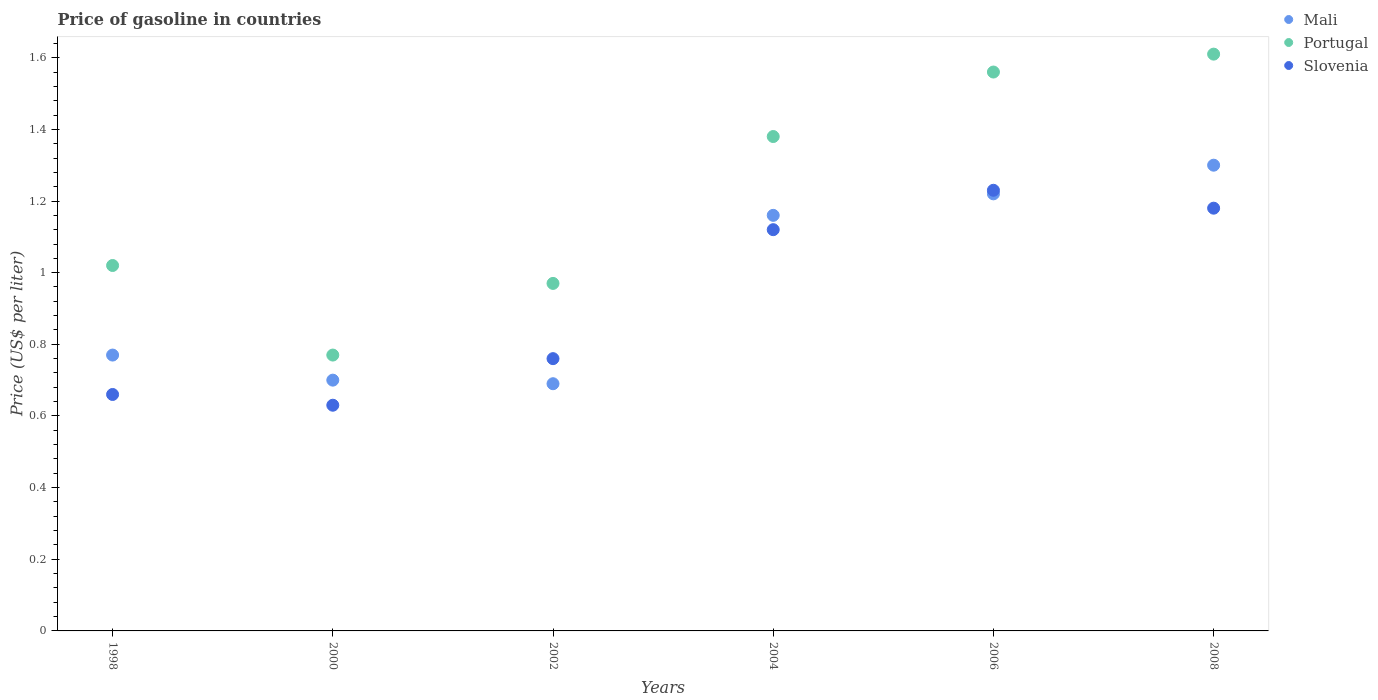How many different coloured dotlines are there?
Give a very brief answer. 3. What is the price of gasoline in Slovenia in 2004?
Keep it short and to the point. 1.12. Across all years, what is the minimum price of gasoline in Slovenia?
Keep it short and to the point. 0.63. In which year was the price of gasoline in Slovenia maximum?
Provide a short and direct response. 2006. In which year was the price of gasoline in Portugal minimum?
Provide a succinct answer. 2000. What is the total price of gasoline in Mali in the graph?
Your response must be concise. 5.84. What is the difference between the price of gasoline in Mali in 1998 and that in 2002?
Your answer should be compact. 0.08. What is the difference between the price of gasoline in Portugal in 2000 and the price of gasoline in Slovenia in 2008?
Offer a very short reply. -0.41. What is the average price of gasoline in Portugal per year?
Offer a very short reply. 1.22. In the year 2006, what is the difference between the price of gasoline in Slovenia and price of gasoline in Portugal?
Make the answer very short. -0.33. What is the ratio of the price of gasoline in Slovenia in 2000 to that in 2004?
Your response must be concise. 0.56. Is the difference between the price of gasoline in Slovenia in 1998 and 2008 greater than the difference between the price of gasoline in Portugal in 1998 and 2008?
Ensure brevity in your answer.  Yes. What is the difference between the highest and the second highest price of gasoline in Slovenia?
Your response must be concise. 0.05. What is the difference between the highest and the lowest price of gasoline in Mali?
Make the answer very short. 0.61. Is the sum of the price of gasoline in Portugal in 2006 and 2008 greater than the maximum price of gasoline in Slovenia across all years?
Make the answer very short. Yes. Is it the case that in every year, the sum of the price of gasoline in Mali and price of gasoline in Portugal  is greater than the price of gasoline in Slovenia?
Provide a succinct answer. Yes. How many years are there in the graph?
Offer a very short reply. 6. Does the graph contain any zero values?
Your response must be concise. No. Where does the legend appear in the graph?
Give a very brief answer. Top right. How many legend labels are there?
Your answer should be compact. 3. What is the title of the graph?
Keep it short and to the point. Price of gasoline in countries. What is the label or title of the Y-axis?
Make the answer very short. Price (US$ per liter). What is the Price (US$ per liter) in Mali in 1998?
Your answer should be compact. 0.77. What is the Price (US$ per liter) of Portugal in 1998?
Your answer should be compact. 1.02. What is the Price (US$ per liter) of Slovenia in 1998?
Make the answer very short. 0.66. What is the Price (US$ per liter) in Mali in 2000?
Make the answer very short. 0.7. What is the Price (US$ per liter) of Portugal in 2000?
Your answer should be compact. 0.77. What is the Price (US$ per liter) of Slovenia in 2000?
Provide a succinct answer. 0.63. What is the Price (US$ per liter) in Mali in 2002?
Your response must be concise. 0.69. What is the Price (US$ per liter) in Slovenia in 2002?
Your answer should be compact. 0.76. What is the Price (US$ per liter) in Mali in 2004?
Provide a short and direct response. 1.16. What is the Price (US$ per liter) in Portugal in 2004?
Give a very brief answer. 1.38. What is the Price (US$ per liter) in Slovenia in 2004?
Provide a short and direct response. 1.12. What is the Price (US$ per liter) in Mali in 2006?
Give a very brief answer. 1.22. What is the Price (US$ per liter) of Portugal in 2006?
Your answer should be very brief. 1.56. What is the Price (US$ per liter) in Slovenia in 2006?
Make the answer very short. 1.23. What is the Price (US$ per liter) of Portugal in 2008?
Your response must be concise. 1.61. What is the Price (US$ per liter) of Slovenia in 2008?
Offer a very short reply. 1.18. Across all years, what is the maximum Price (US$ per liter) of Mali?
Provide a succinct answer. 1.3. Across all years, what is the maximum Price (US$ per liter) in Portugal?
Offer a terse response. 1.61. Across all years, what is the maximum Price (US$ per liter) of Slovenia?
Your answer should be compact. 1.23. Across all years, what is the minimum Price (US$ per liter) of Mali?
Provide a succinct answer. 0.69. Across all years, what is the minimum Price (US$ per liter) of Portugal?
Keep it short and to the point. 0.77. Across all years, what is the minimum Price (US$ per liter) of Slovenia?
Keep it short and to the point. 0.63. What is the total Price (US$ per liter) in Mali in the graph?
Offer a very short reply. 5.84. What is the total Price (US$ per liter) in Portugal in the graph?
Keep it short and to the point. 7.31. What is the total Price (US$ per liter) of Slovenia in the graph?
Make the answer very short. 5.58. What is the difference between the Price (US$ per liter) of Mali in 1998 and that in 2000?
Offer a very short reply. 0.07. What is the difference between the Price (US$ per liter) in Portugal in 1998 and that in 2000?
Keep it short and to the point. 0.25. What is the difference between the Price (US$ per liter) in Mali in 1998 and that in 2002?
Keep it short and to the point. 0.08. What is the difference between the Price (US$ per liter) of Portugal in 1998 and that in 2002?
Offer a very short reply. 0.05. What is the difference between the Price (US$ per liter) in Slovenia in 1998 and that in 2002?
Provide a succinct answer. -0.1. What is the difference between the Price (US$ per liter) in Mali in 1998 and that in 2004?
Make the answer very short. -0.39. What is the difference between the Price (US$ per liter) in Portugal in 1998 and that in 2004?
Give a very brief answer. -0.36. What is the difference between the Price (US$ per liter) in Slovenia in 1998 and that in 2004?
Offer a very short reply. -0.46. What is the difference between the Price (US$ per liter) of Mali in 1998 and that in 2006?
Provide a succinct answer. -0.45. What is the difference between the Price (US$ per liter) of Portugal in 1998 and that in 2006?
Your answer should be very brief. -0.54. What is the difference between the Price (US$ per liter) of Slovenia in 1998 and that in 2006?
Ensure brevity in your answer.  -0.57. What is the difference between the Price (US$ per liter) of Mali in 1998 and that in 2008?
Your answer should be very brief. -0.53. What is the difference between the Price (US$ per liter) of Portugal in 1998 and that in 2008?
Ensure brevity in your answer.  -0.59. What is the difference between the Price (US$ per liter) in Slovenia in 1998 and that in 2008?
Give a very brief answer. -0.52. What is the difference between the Price (US$ per liter) of Slovenia in 2000 and that in 2002?
Make the answer very short. -0.13. What is the difference between the Price (US$ per liter) of Mali in 2000 and that in 2004?
Your response must be concise. -0.46. What is the difference between the Price (US$ per liter) in Portugal in 2000 and that in 2004?
Keep it short and to the point. -0.61. What is the difference between the Price (US$ per liter) of Slovenia in 2000 and that in 2004?
Offer a terse response. -0.49. What is the difference between the Price (US$ per liter) of Mali in 2000 and that in 2006?
Provide a short and direct response. -0.52. What is the difference between the Price (US$ per liter) in Portugal in 2000 and that in 2006?
Provide a succinct answer. -0.79. What is the difference between the Price (US$ per liter) of Mali in 2000 and that in 2008?
Provide a succinct answer. -0.6. What is the difference between the Price (US$ per liter) of Portugal in 2000 and that in 2008?
Make the answer very short. -0.84. What is the difference between the Price (US$ per liter) in Slovenia in 2000 and that in 2008?
Your answer should be very brief. -0.55. What is the difference between the Price (US$ per liter) in Mali in 2002 and that in 2004?
Offer a terse response. -0.47. What is the difference between the Price (US$ per liter) in Portugal in 2002 and that in 2004?
Keep it short and to the point. -0.41. What is the difference between the Price (US$ per liter) in Slovenia in 2002 and that in 2004?
Offer a terse response. -0.36. What is the difference between the Price (US$ per liter) of Mali in 2002 and that in 2006?
Give a very brief answer. -0.53. What is the difference between the Price (US$ per liter) in Portugal in 2002 and that in 2006?
Your answer should be compact. -0.59. What is the difference between the Price (US$ per liter) in Slovenia in 2002 and that in 2006?
Keep it short and to the point. -0.47. What is the difference between the Price (US$ per liter) in Mali in 2002 and that in 2008?
Your response must be concise. -0.61. What is the difference between the Price (US$ per liter) in Portugal in 2002 and that in 2008?
Provide a short and direct response. -0.64. What is the difference between the Price (US$ per liter) in Slovenia in 2002 and that in 2008?
Make the answer very short. -0.42. What is the difference between the Price (US$ per liter) of Mali in 2004 and that in 2006?
Your answer should be very brief. -0.06. What is the difference between the Price (US$ per liter) of Portugal in 2004 and that in 2006?
Your response must be concise. -0.18. What is the difference between the Price (US$ per liter) in Slovenia in 2004 and that in 2006?
Provide a short and direct response. -0.11. What is the difference between the Price (US$ per liter) in Mali in 2004 and that in 2008?
Make the answer very short. -0.14. What is the difference between the Price (US$ per liter) in Portugal in 2004 and that in 2008?
Give a very brief answer. -0.23. What is the difference between the Price (US$ per liter) of Slovenia in 2004 and that in 2008?
Offer a terse response. -0.06. What is the difference between the Price (US$ per liter) of Mali in 2006 and that in 2008?
Keep it short and to the point. -0.08. What is the difference between the Price (US$ per liter) of Portugal in 2006 and that in 2008?
Your answer should be very brief. -0.05. What is the difference between the Price (US$ per liter) in Slovenia in 2006 and that in 2008?
Your answer should be very brief. 0.05. What is the difference between the Price (US$ per liter) of Mali in 1998 and the Price (US$ per liter) of Portugal in 2000?
Give a very brief answer. 0. What is the difference between the Price (US$ per liter) in Mali in 1998 and the Price (US$ per liter) in Slovenia in 2000?
Your response must be concise. 0.14. What is the difference between the Price (US$ per liter) of Portugal in 1998 and the Price (US$ per liter) of Slovenia in 2000?
Keep it short and to the point. 0.39. What is the difference between the Price (US$ per liter) in Mali in 1998 and the Price (US$ per liter) in Portugal in 2002?
Your response must be concise. -0.2. What is the difference between the Price (US$ per liter) of Mali in 1998 and the Price (US$ per liter) of Slovenia in 2002?
Provide a succinct answer. 0.01. What is the difference between the Price (US$ per liter) of Portugal in 1998 and the Price (US$ per liter) of Slovenia in 2002?
Keep it short and to the point. 0.26. What is the difference between the Price (US$ per liter) in Mali in 1998 and the Price (US$ per liter) in Portugal in 2004?
Provide a succinct answer. -0.61. What is the difference between the Price (US$ per liter) in Mali in 1998 and the Price (US$ per liter) in Slovenia in 2004?
Make the answer very short. -0.35. What is the difference between the Price (US$ per liter) in Portugal in 1998 and the Price (US$ per liter) in Slovenia in 2004?
Keep it short and to the point. -0.1. What is the difference between the Price (US$ per liter) of Mali in 1998 and the Price (US$ per liter) of Portugal in 2006?
Keep it short and to the point. -0.79. What is the difference between the Price (US$ per liter) in Mali in 1998 and the Price (US$ per liter) in Slovenia in 2006?
Keep it short and to the point. -0.46. What is the difference between the Price (US$ per liter) in Portugal in 1998 and the Price (US$ per liter) in Slovenia in 2006?
Your answer should be compact. -0.21. What is the difference between the Price (US$ per liter) of Mali in 1998 and the Price (US$ per liter) of Portugal in 2008?
Offer a very short reply. -0.84. What is the difference between the Price (US$ per liter) in Mali in 1998 and the Price (US$ per liter) in Slovenia in 2008?
Offer a very short reply. -0.41. What is the difference between the Price (US$ per liter) of Portugal in 1998 and the Price (US$ per liter) of Slovenia in 2008?
Offer a very short reply. -0.16. What is the difference between the Price (US$ per liter) in Mali in 2000 and the Price (US$ per liter) in Portugal in 2002?
Provide a short and direct response. -0.27. What is the difference between the Price (US$ per liter) of Mali in 2000 and the Price (US$ per liter) of Slovenia in 2002?
Offer a very short reply. -0.06. What is the difference between the Price (US$ per liter) in Mali in 2000 and the Price (US$ per liter) in Portugal in 2004?
Your response must be concise. -0.68. What is the difference between the Price (US$ per liter) in Mali in 2000 and the Price (US$ per liter) in Slovenia in 2004?
Ensure brevity in your answer.  -0.42. What is the difference between the Price (US$ per liter) of Portugal in 2000 and the Price (US$ per liter) of Slovenia in 2004?
Provide a succinct answer. -0.35. What is the difference between the Price (US$ per liter) in Mali in 2000 and the Price (US$ per liter) in Portugal in 2006?
Give a very brief answer. -0.86. What is the difference between the Price (US$ per liter) of Mali in 2000 and the Price (US$ per liter) of Slovenia in 2006?
Offer a very short reply. -0.53. What is the difference between the Price (US$ per liter) of Portugal in 2000 and the Price (US$ per liter) of Slovenia in 2006?
Your answer should be compact. -0.46. What is the difference between the Price (US$ per liter) in Mali in 2000 and the Price (US$ per liter) in Portugal in 2008?
Ensure brevity in your answer.  -0.91. What is the difference between the Price (US$ per liter) of Mali in 2000 and the Price (US$ per liter) of Slovenia in 2008?
Offer a very short reply. -0.48. What is the difference between the Price (US$ per liter) of Portugal in 2000 and the Price (US$ per liter) of Slovenia in 2008?
Provide a succinct answer. -0.41. What is the difference between the Price (US$ per liter) in Mali in 2002 and the Price (US$ per liter) in Portugal in 2004?
Your answer should be very brief. -0.69. What is the difference between the Price (US$ per liter) in Mali in 2002 and the Price (US$ per liter) in Slovenia in 2004?
Your answer should be compact. -0.43. What is the difference between the Price (US$ per liter) in Portugal in 2002 and the Price (US$ per liter) in Slovenia in 2004?
Ensure brevity in your answer.  -0.15. What is the difference between the Price (US$ per liter) of Mali in 2002 and the Price (US$ per liter) of Portugal in 2006?
Offer a very short reply. -0.87. What is the difference between the Price (US$ per liter) in Mali in 2002 and the Price (US$ per liter) in Slovenia in 2006?
Offer a very short reply. -0.54. What is the difference between the Price (US$ per liter) in Portugal in 2002 and the Price (US$ per liter) in Slovenia in 2006?
Keep it short and to the point. -0.26. What is the difference between the Price (US$ per liter) of Mali in 2002 and the Price (US$ per liter) of Portugal in 2008?
Ensure brevity in your answer.  -0.92. What is the difference between the Price (US$ per liter) in Mali in 2002 and the Price (US$ per liter) in Slovenia in 2008?
Provide a short and direct response. -0.49. What is the difference between the Price (US$ per liter) of Portugal in 2002 and the Price (US$ per liter) of Slovenia in 2008?
Make the answer very short. -0.21. What is the difference between the Price (US$ per liter) of Mali in 2004 and the Price (US$ per liter) of Portugal in 2006?
Keep it short and to the point. -0.4. What is the difference between the Price (US$ per liter) of Mali in 2004 and the Price (US$ per liter) of Slovenia in 2006?
Your answer should be compact. -0.07. What is the difference between the Price (US$ per liter) in Portugal in 2004 and the Price (US$ per liter) in Slovenia in 2006?
Your response must be concise. 0.15. What is the difference between the Price (US$ per liter) in Mali in 2004 and the Price (US$ per liter) in Portugal in 2008?
Your answer should be compact. -0.45. What is the difference between the Price (US$ per liter) of Mali in 2004 and the Price (US$ per liter) of Slovenia in 2008?
Keep it short and to the point. -0.02. What is the difference between the Price (US$ per liter) in Portugal in 2004 and the Price (US$ per liter) in Slovenia in 2008?
Provide a short and direct response. 0.2. What is the difference between the Price (US$ per liter) of Mali in 2006 and the Price (US$ per liter) of Portugal in 2008?
Give a very brief answer. -0.39. What is the difference between the Price (US$ per liter) in Portugal in 2006 and the Price (US$ per liter) in Slovenia in 2008?
Provide a succinct answer. 0.38. What is the average Price (US$ per liter) of Mali per year?
Give a very brief answer. 0.97. What is the average Price (US$ per liter) of Portugal per year?
Give a very brief answer. 1.22. In the year 1998, what is the difference between the Price (US$ per liter) of Mali and Price (US$ per liter) of Slovenia?
Keep it short and to the point. 0.11. In the year 1998, what is the difference between the Price (US$ per liter) in Portugal and Price (US$ per liter) in Slovenia?
Ensure brevity in your answer.  0.36. In the year 2000, what is the difference between the Price (US$ per liter) of Mali and Price (US$ per liter) of Portugal?
Keep it short and to the point. -0.07. In the year 2000, what is the difference between the Price (US$ per liter) of Mali and Price (US$ per liter) of Slovenia?
Your response must be concise. 0.07. In the year 2000, what is the difference between the Price (US$ per liter) in Portugal and Price (US$ per liter) in Slovenia?
Your answer should be compact. 0.14. In the year 2002, what is the difference between the Price (US$ per liter) in Mali and Price (US$ per liter) in Portugal?
Offer a very short reply. -0.28. In the year 2002, what is the difference between the Price (US$ per liter) in Mali and Price (US$ per liter) in Slovenia?
Ensure brevity in your answer.  -0.07. In the year 2002, what is the difference between the Price (US$ per liter) of Portugal and Price (US$ per liter) of Slovenia?
Ensure brevity in your answer.  0.21. In the year 2004, what is the difference between the Price (US$ per liter) of Mali and Price (US$ per liter) of Portugal?
Give a very brief answer. -0.22. In the year 2004, what is the difference between the Price (US$ per liter) of Portugal and Price (US$ per liter) of Slovenia?
Provide a short and direct response. 0.26. In the year 2006, what is the difference between the Price (US$ per liter) in Mali and Price (US$ per liter) in Portugal?
Keep it short and to the point. -0.34. In the year 2006, what is the difference between the Price (US$ per liter) in Mali and Price (US$ per liter) in Slovenia?
Ensure brevity in your answer.  -0.01. In the year 2006, what is the difference between the Price (US$ per liter) of Portugal and Price (US$ per liter) of Slovenia?
Offer a terse response. 0.33. In the year 2008, what is the difference between the Price (US$ per liter) of Mali and Price (US$ per liter) of Portugal?
Give a very brief answer. -0.31. In the year 2008, what is the difference between the Price (US$ per liter) in Mali and Price (US$ per liter) in Slovenia?
Keep it short and to the point. 0.12. In the year 2008, what is the difference between the Price (US$ per liter) of Portugal and Price (US$ per liter) of Slovenia?
Offer a terse response. 0.43. What is the ratio of the Price (US$ per liter) in Mali in 1998 to that in 2000?
Keep it short and to the point. 1.1. What is the ratio of the Price (US$ per liter) in Portugal in 1998 to that in 2000?
Provide a succinct answer. 1.32. What is the ratio of the Price (US$ per liter) of Slovenia in 1998 to that in 2000?
Make the answer very short. 1.05. What is the ratio of the Price (US$ per liter) of Mali in 1998 to that in 2002?
Ensure brevity in your answer.  1.12. What is the ratio of the Price (US$ per liter) in Portugal in 1998 to that in 2002?
Your answer should be compact. 1.05. What is the ratio of the Price (US$ per liter) of Slovenia in 1998 to that in 2002?
Your response must be concise. 0.87. What is the ratio of the Price (US$ per liter) of Mali in 1998 to that in 2004?
Make the answer very short. 0.66. What is the ratio of the Price (US$ per liter) of Portugal in 1998 to that in 2004?
Give a very brief answer. 0.74. What is the ratio of the Price (US$ per liter) in Slovenia in 1998 to that in 2004?
Give a very brief answer. 0.59. What is the ratio of the Price (US$ per liter) of Mali in 1998 to that in 2006?
Your answer should be compact. 0.63. What is the ratio of the Price (US$ per liter) in Portugal in 1998 to that in 2006?
Ensure brevity in your answer.  0.65. What is the ratio of the Price (US$ per liter) in Slovenia in 1998 to that in 2006?
Provide a short and direct response. 0.54. What is the ratio of the Price (US$ per liter) in Mali in 1998 to that in 2008?
Your answer should be very brief. 0.59. What is the ratio of the Price (US$ per liter) of Portugal in 1998 to that in 2008?
Provide a short and direct response. 0.63. What is the ratio of the Price (US$ per liter) in Slovenia in 1998 to that in 2008?
Keep it short and to the point. 0.56. What is the ratio of the Price (US$ per liter) of Mali in 2000 to that in 2002?
Make the answer very short. 1.01. What is the ratio of the Price (US$ per liter) in Portugal in 2000 to that in 2002?
Give a very brief answer. 0.79. What is the ratio of the Price (US$ per liter) of Slovenia in 2000 to that in 2002?
Provide a short and direct response. 0.83. What is the ratio of the Price (US$ per liter) of Mali in 2000 to that in 2004?
Your answer should be compact. 0.6. What is the ratio of the Price (US$ per liter) of Portugal in 2000 to that in 2004?
Offer a terse response. 0.56. What is the ratio of the Price (US$ per liter) of Slovenia in 2000 to that in 2004?
Your response must be concise. 0.56. What is the ratio of the Price (US$ per liter) of Mali in 2000 to that in 2006?
Provide a succinct answer. 0.57. What is the ratio of the Price (US$ per liter) of Portugal in 2000 to that in 2006?
Offer a very short reply. 0.49. What is the ratio of the Price (US$ per liter) in Slovenia in 2000 to that in 2006?
Your answer should be very brief. 0.51. What is the ratio of the Price (US$ per liter) of Mali in 2000 to that in 2008?
Offer a very short reply. 0.54. What is the ratio of the Price (US$ per liter) of Portugal in 2000 to that in 2008?
Ensure brevity in your answer.  0.48. What is the ratio of the Price (US$ per liter) of Slovenia in 2000 to that in 2008?
Give a very brief answer. 0.53. What is the ratio of the Price (US$ per liter) in Mali in 2002 to that in 2004?
Provide a short and direct response. 0.59. What is the ratio of the Price (US$ per liter) of Portugal in 2002 to that in 2004?
Offer a terse response. 0.7. What is the ratio of the Price (US$ per liter) in Slovenia in 2002 to that in 2004?
Your answer should be very brief. 0.68. What is the ratio of the Price (US$ per liter) of Mali in 2002 to that in 2006?
Your answer should be compact. 0.57. What is the ratio of the Price (US$ per liter) in Portugal in 2002 to that in 2006?
Ensure brevity in your answer.  0.62. What is the ratio of the Price (US$ per liter) of Slovenia in 2002 to that in 2006?
Ensure brevity in your answer.  0.62. What is the ratio of the Price (US$ per liter) in Mali in 2002 to that in 2008?
Offer a terse response. 0.53. What is the ratio of the Price (US$ per liter) of Portugal in 2002 to that in 2008?
Keep it short and to the point. 0.6. What is the ratio of the Price (US$ per liter) in Slovenia in 2002 to that in 2008?
Provide a short and direct response. 0.64. What is the ratio of the Price (US$ per liter) of Mali in 2004 to that in 2006?
Your answer should be compact. 0.95. What is the ratio of the Price (US$ per liter) of Portugal in 2004 to that in 2006?
Provide a succinct answer. 0.88. What is the ratio of the Price (US$ per liter) in Slovenia in 2004 to that in 2006?
Offer a very short reply. 0.91. What is the ratio of the Price (US$ per liter) of Mali in 2004 to that in 2008?
Provide a short and direct response. 0.89. What is the ratio of the Price (US$ per liter) in Portugal in 2004 to that in 2008?
Offer a very short reply. 0.86. What is the ratio of the Price (US$ per liter) of Slovenia in 2004 to that in 2008?
Ensure brevity in your answer.  0.95. What is the ratio of the Price (US$ per liter) in Mali in 2006 to that in 2008?
Your response must be concise. 0.94. What is the ratio of the Price (US$ per liter) in Portugal in 2006 to that in 2008?
Offer a terse response. 0.97. What is the ratio of the Price (US$ per liter) of Slovenia in 2006 to that in 2008?
Offer a terse response. 1.04. What is the difference between the highest and the second highest Price (US$ per liter) of Mali?
Make the answer very short. 0.08. What is the difference between the highest and the second highest Price (US$ per liter) in Portugal?
Ensure brevity in your answer.  0.05. What is the difference between the highest and the lowest Price (US$ per liter) in Mali?
Ensure brevity in your answer.  0.61. What is the difference between the highest and the lowest Price (US$ per liter) of Portugal?
Your answer should be very brief. 0.84. What is the difference between the highest and the lowest Price (US$ per liter) in Slovenia?
Give a very brief answer. 0.6. 